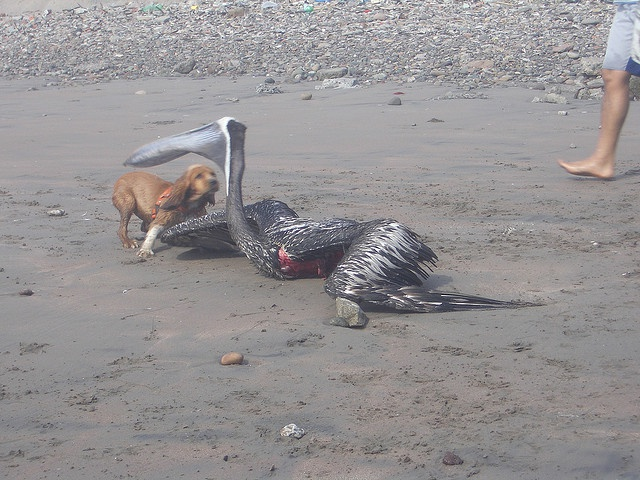Describe the objects in this image and their specific colors. I can see bird in darkgray, gray, lightgray, and black tones, people in darkgray, lightgray, tan, and gray tones, and dog in darkgray, gray, and tan tones in this image. 